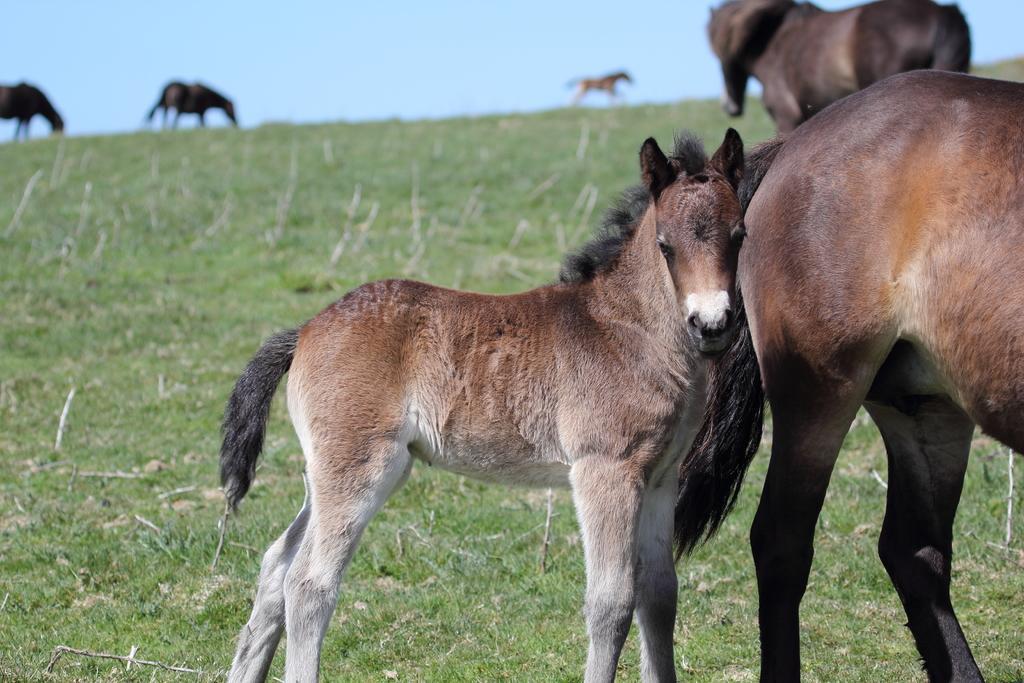Can you describe this image briefly? In this image the horses in a field,in the background three horses are grazing in the field. 